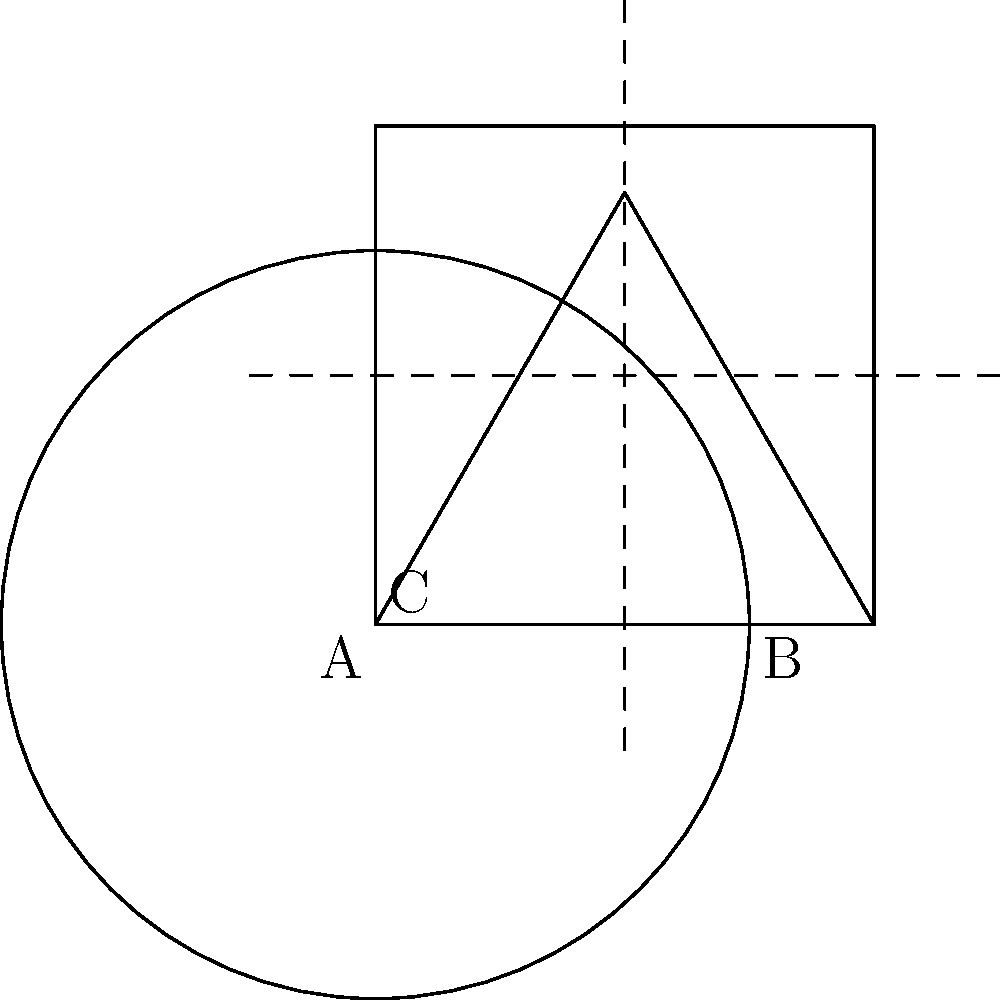You have a detailed line illustration that needs to be scaled to fit within three different geometric shapes: a square (A), a circle (B), and an equilateral triangle (C). The illustration must maintain its proportions and touch at least two sides of each shape without exceeding the boundaries. If the original illustration has dimensions of 10 inches by 8 inches, what is the maximum area (in square inches) that the scaled illustration can occupy when fitted into shape B? To solve this problem, we need to follow these steps:

1. Determine the scaling factor for each shape:
   - For the square (A): The scaling factor is the minimum of width and height ratios.
   - For the circle (B): The scaling factor is the diameter of the circle divided by the larger dimension of the illustration.
   - For the triangle (C): The scaling factor is the height of the triangle divided by the height of the illustration.

2. Focus on shape B (the circle) as per the question:
   - The diameter of the circle is 3 units (1.5 * 2) in the given scale.
   - The larger dimension of the original illustration is 10 inches.

3. Calculate the scaling factor for the circle:
   Scaling factor = 3 / 10 = 0.3

4. Apply the scaling factor to both dimensions of the original illustration:
   New width = 10 * 0.3 = 3 inches
   New height = 8 * 0.3 = 2.4 inches

5. Calculate the area of the scaled illustration:
   Area = New width * New height
   Area = 3 * 2.4 = 7.2 square inches

Therefore, the maximum area that the scaled illustration can occupy when fitted into shape B (the circle) is 7.2 square inches.
Answer: 7.2 square inches 